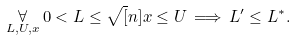Convert formula to latex. <formula><loc_0><loc_0><loc_500><loc_500>\underset { L , U , x } { \forall } \, 0 < L \leq \sqrt { [ } n ] { x } \leq U \, \Longrightarrow \, L ^ { \prime } \leq L ^ { \ast } .</formula> 